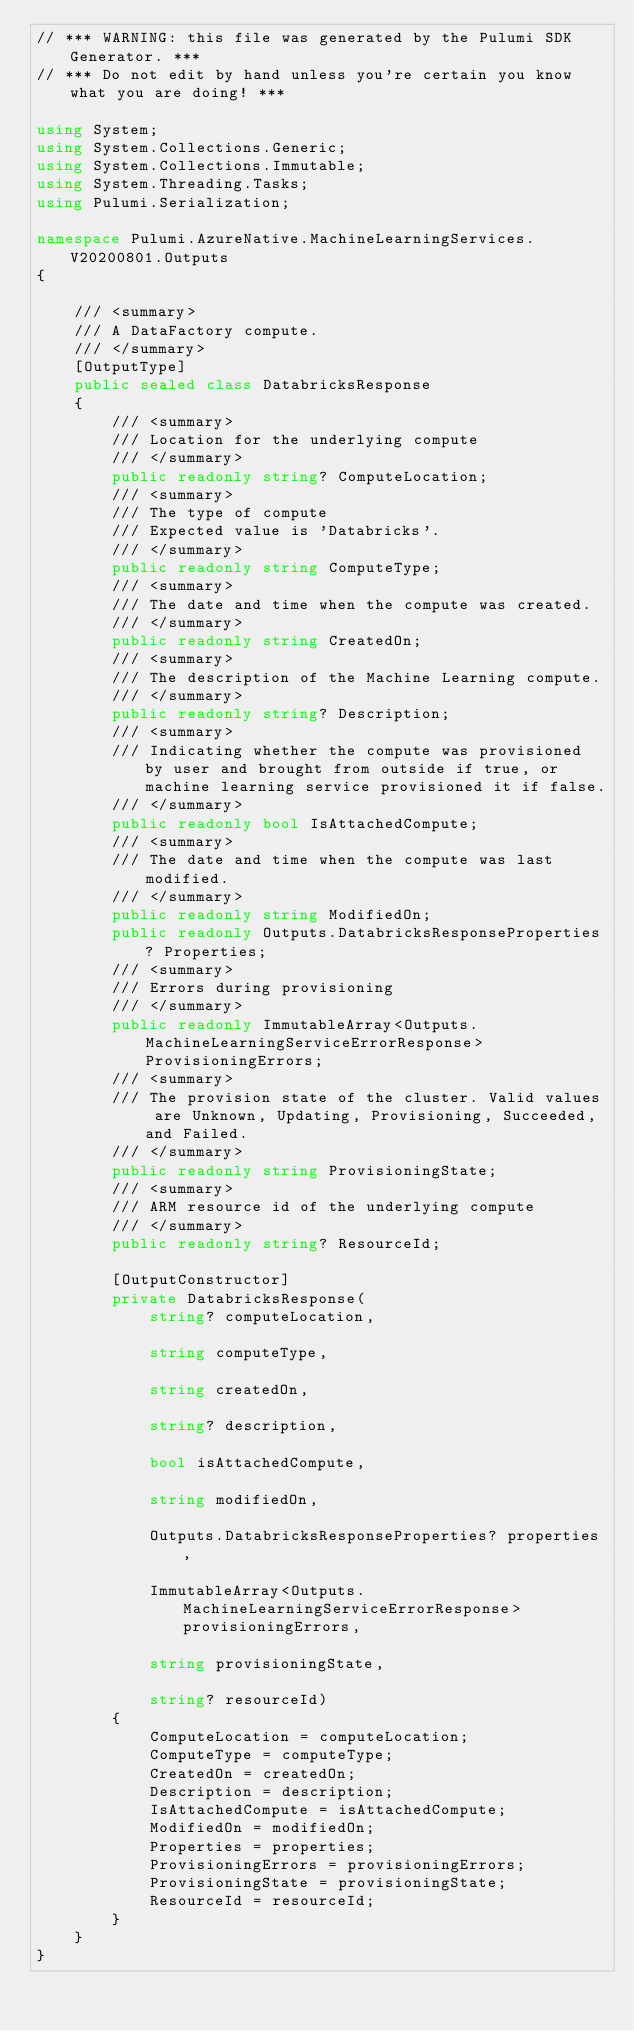<code> <loc_0><loc_0><loc_500><loc_500><_C#_>// *** WARNING: this file was generated by the Pulumi SDK Generator. ***
// *** Do not edit by hand unless you're certain you know what you are doing! ***

using System;
using System.Collections.Generic;
using System.Collections.Immutable;
using System.Threading.Tasks;
using Pulumi.Serialization;

namespace Pulumi.AzureNative.MachineLearningServices.V20200801.Outputs
{

    /// <summary>
    /// A DataFactory compute.
    /// </summary>
    [OutputType]
    public sealed class DatabricksResponse
    {
        /// <summary>
        /// Location for the underlying compute
        /// </summary>
        public readonly string? ComputeLocation;
        /// <summary>
        /// The type of compute
        /// Expected value is 'Databricks'.
        /// </summary>
        public readonly string ComputeType;
        /// <summary>
        /// The date and time when the compute was created.
        /// </summary>
        public readonly string CreatedOn;
        /// <summary>
        /// The description of the Machine Learning compute.
        /// </summary>
        public readonly string? Description;
        /// <summary>
        /// Indicating whether the compute was provisioned by user and brought from outside if true, or machine learning service provisioned it if false.
        /// </summary>
        public readonly bool IsAttachedCompute;
        /// <summary>
        /// The date and time when the compute was last modified.
        /// </summary>
        public readonly string ModifiedOn;
        public readonly Outputs.DatabricksResponseProperties? Properties;
        /// <summary>
        /// Errors during provisioning
        /// </summary>
        public readonly ImmutableArray<Outputs.MachineLearningServiceErrorResponse> ProvisioningErrors;
        /// <summary>
        /// The provision state of the cluster. Valid values are Unknown, Updating, Provisioning, Succeeded, and Failed.
        /// </summary>
        public readonly string ProvisioningState;
        /// <summary>
        /// ARM resource id of the underlying compute
        /// </summary>
        public readonly string? ResourceId;

        [OutputConstructor]
        private DatabricksResponse(
            string? computeLocation,

            string computeType,

            string createdOn,

            string? description,

            bool isAttachedCompute,

            string modifiedOn,

            Outputs.DatabricksResponseProperties? properties,

            ImmutableArray<Outputs.MachineLearningServiceErrorResponse> provisioningErrors,

            string provisioningState,

            string? resourceId)
        {
            ComputeLocation = computeLocation;
            ComputeType = computeType;
            CreatedOn = createdOn;
            Description = description;
            IsAttachedCompute = isAttachedCompute;
            ModifiedOn = modifiedOn;
            Properties = properties;
            ProvisioningErrors = provisioningErrors;
            ProvisioningState = provisioningState;
            ResourceId = resourceId;
        }
    }
}
</code> 